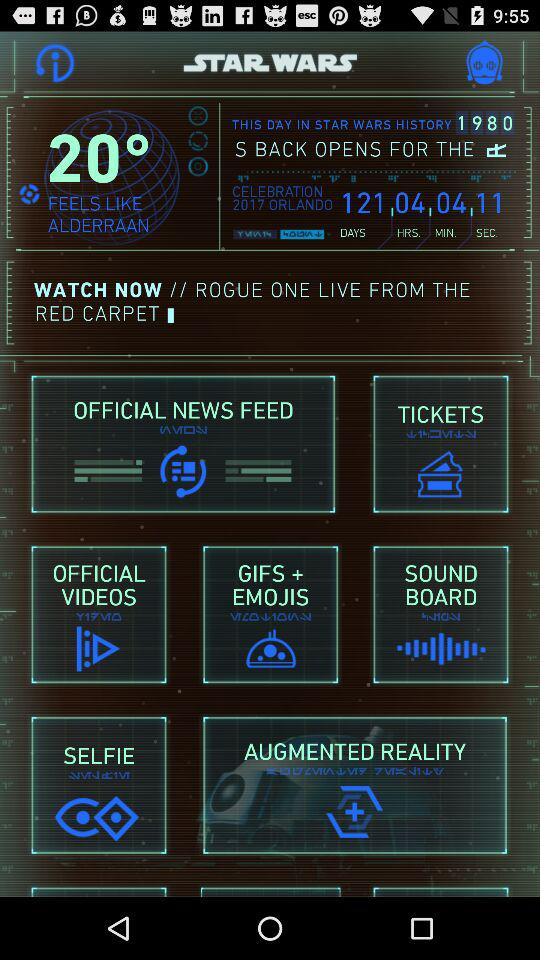What is the shown year? The year is 1980. 